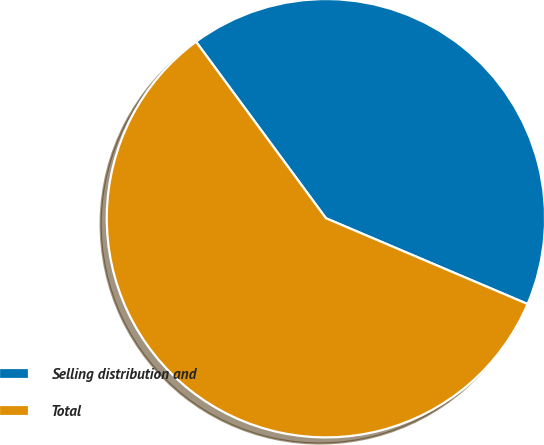Convert chart. <chart><loc_0><loc_0><loc_500><loc_500><pie_chart><fcel>Selling distribution and<fcel>Total<nl><fcel>41.5%<fcel>58.5%<nl></chart> 